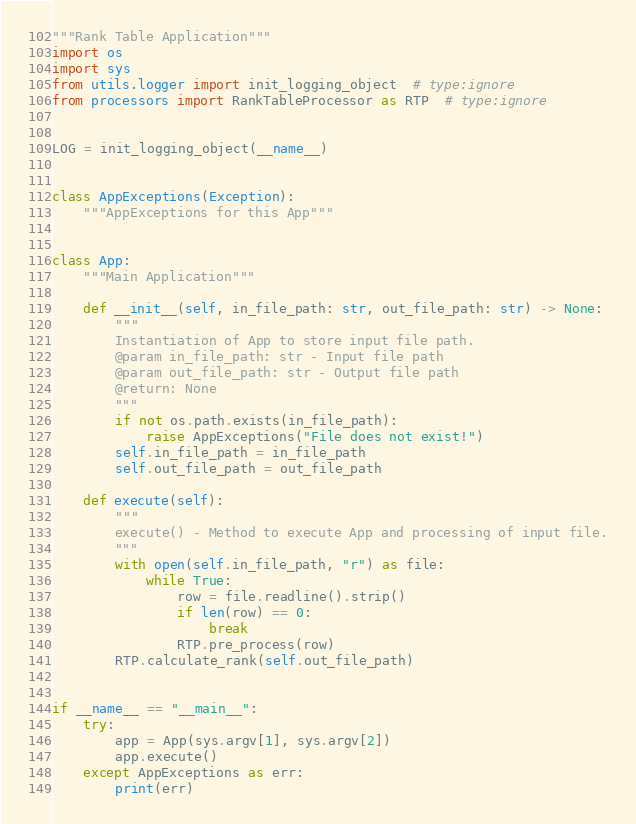<code> <loc_0><loc_0><loc_500><loc_500><_Python_>"""Rank Table Application"""
import os
import sys
from utils.logger import init_logging_object  # type:ignore
from processors import RankTableProcessor as RTP  # type:ignore


LOG = init_logging_object(__name__)


class AppExceptions(Exception):
    """AppExceptions for this App"""


class App:
    """Main Application"""

    def __init__(self, in_file_path: str, out_file_path: str) -> None:
        """
        Instantiation of App to store input file path.
        @param in_file_path: str - Input file path
        @param out_file_path: str - Output file path
        @return: None
        """
        if not os.path.exists(in_file_path):
            raise AppExceptions("File does not exist!")
        self.in_file_path = in_file_path
        self.out_file_path = out_file_path

    def execute(self):
        """
        execute() - Method to execute App and processing of input file.
        """
        with open(self.in_file_path, "r") as file:
            while True:
                row = file.readline().strip()
                if len(row) == 0:
                    break
                RTP.pre_process(row)
        RTP.calculate_rank(self.out_file_path)


if __name__ == "__main__":
    try:
        app = App(sys.argv[1], sys.argv[2])
        app.execute()
    except AppExceptions as err:
        print(err)
</code> 